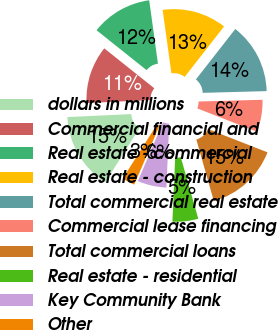<chart> <loc_0><loc_0><loc_500><loc_500><pie_chart><fcel>dollars in millions<fcel>Commercial financial and<fcel>Real estate - commercial<fcel>Real estate - construction<fcel>Total commercial real estate<fcel>Commercial lease financing<fcel>Total commercial loans<fcel>Real estate - residential<fcel>Key Community Bank<fcel>Other<nl><fcel>15.28%<fcel>11.46%<fcel>12.1%<fcel>12.74%<fcel>14.01%<fcel>6.37%<fcel>14.65%<fcel>5.1%<fcel>5.74%<fcel>2.55%<nl></chart> 